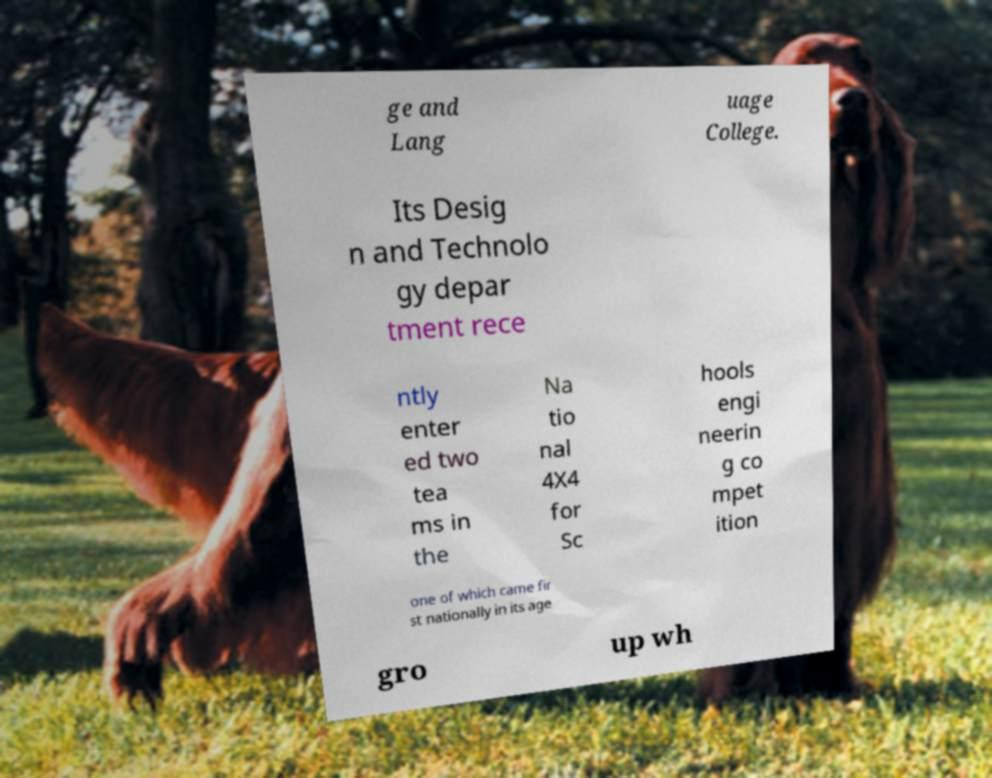I need the written content from this picture converted into text. Can you do that? ge and Lang uage College. Its Desig n and Technolo gy depar tment rece ntly enter ed two tea ms in the Na tio nal 4X4 for Sc hools engi neerin g co mpet ition one of which came fir st nationally in its age gro up wh 